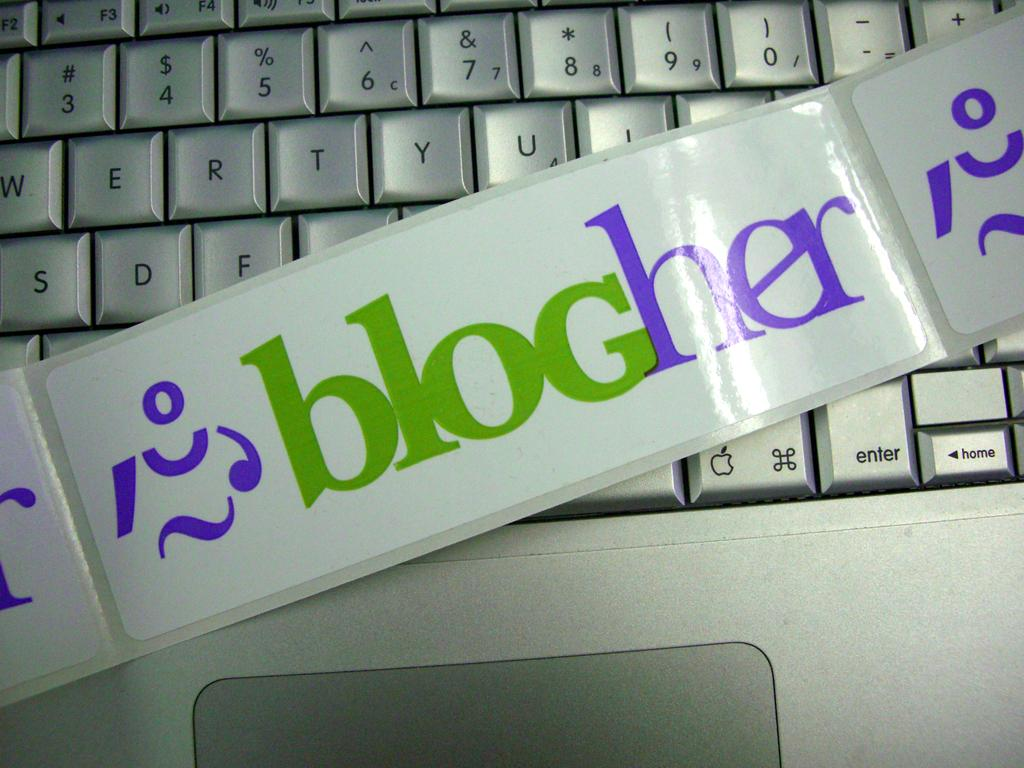<image>
Summarize the visual content of the image. Green and purple sticker saying Blogher on top of a keyboard. 